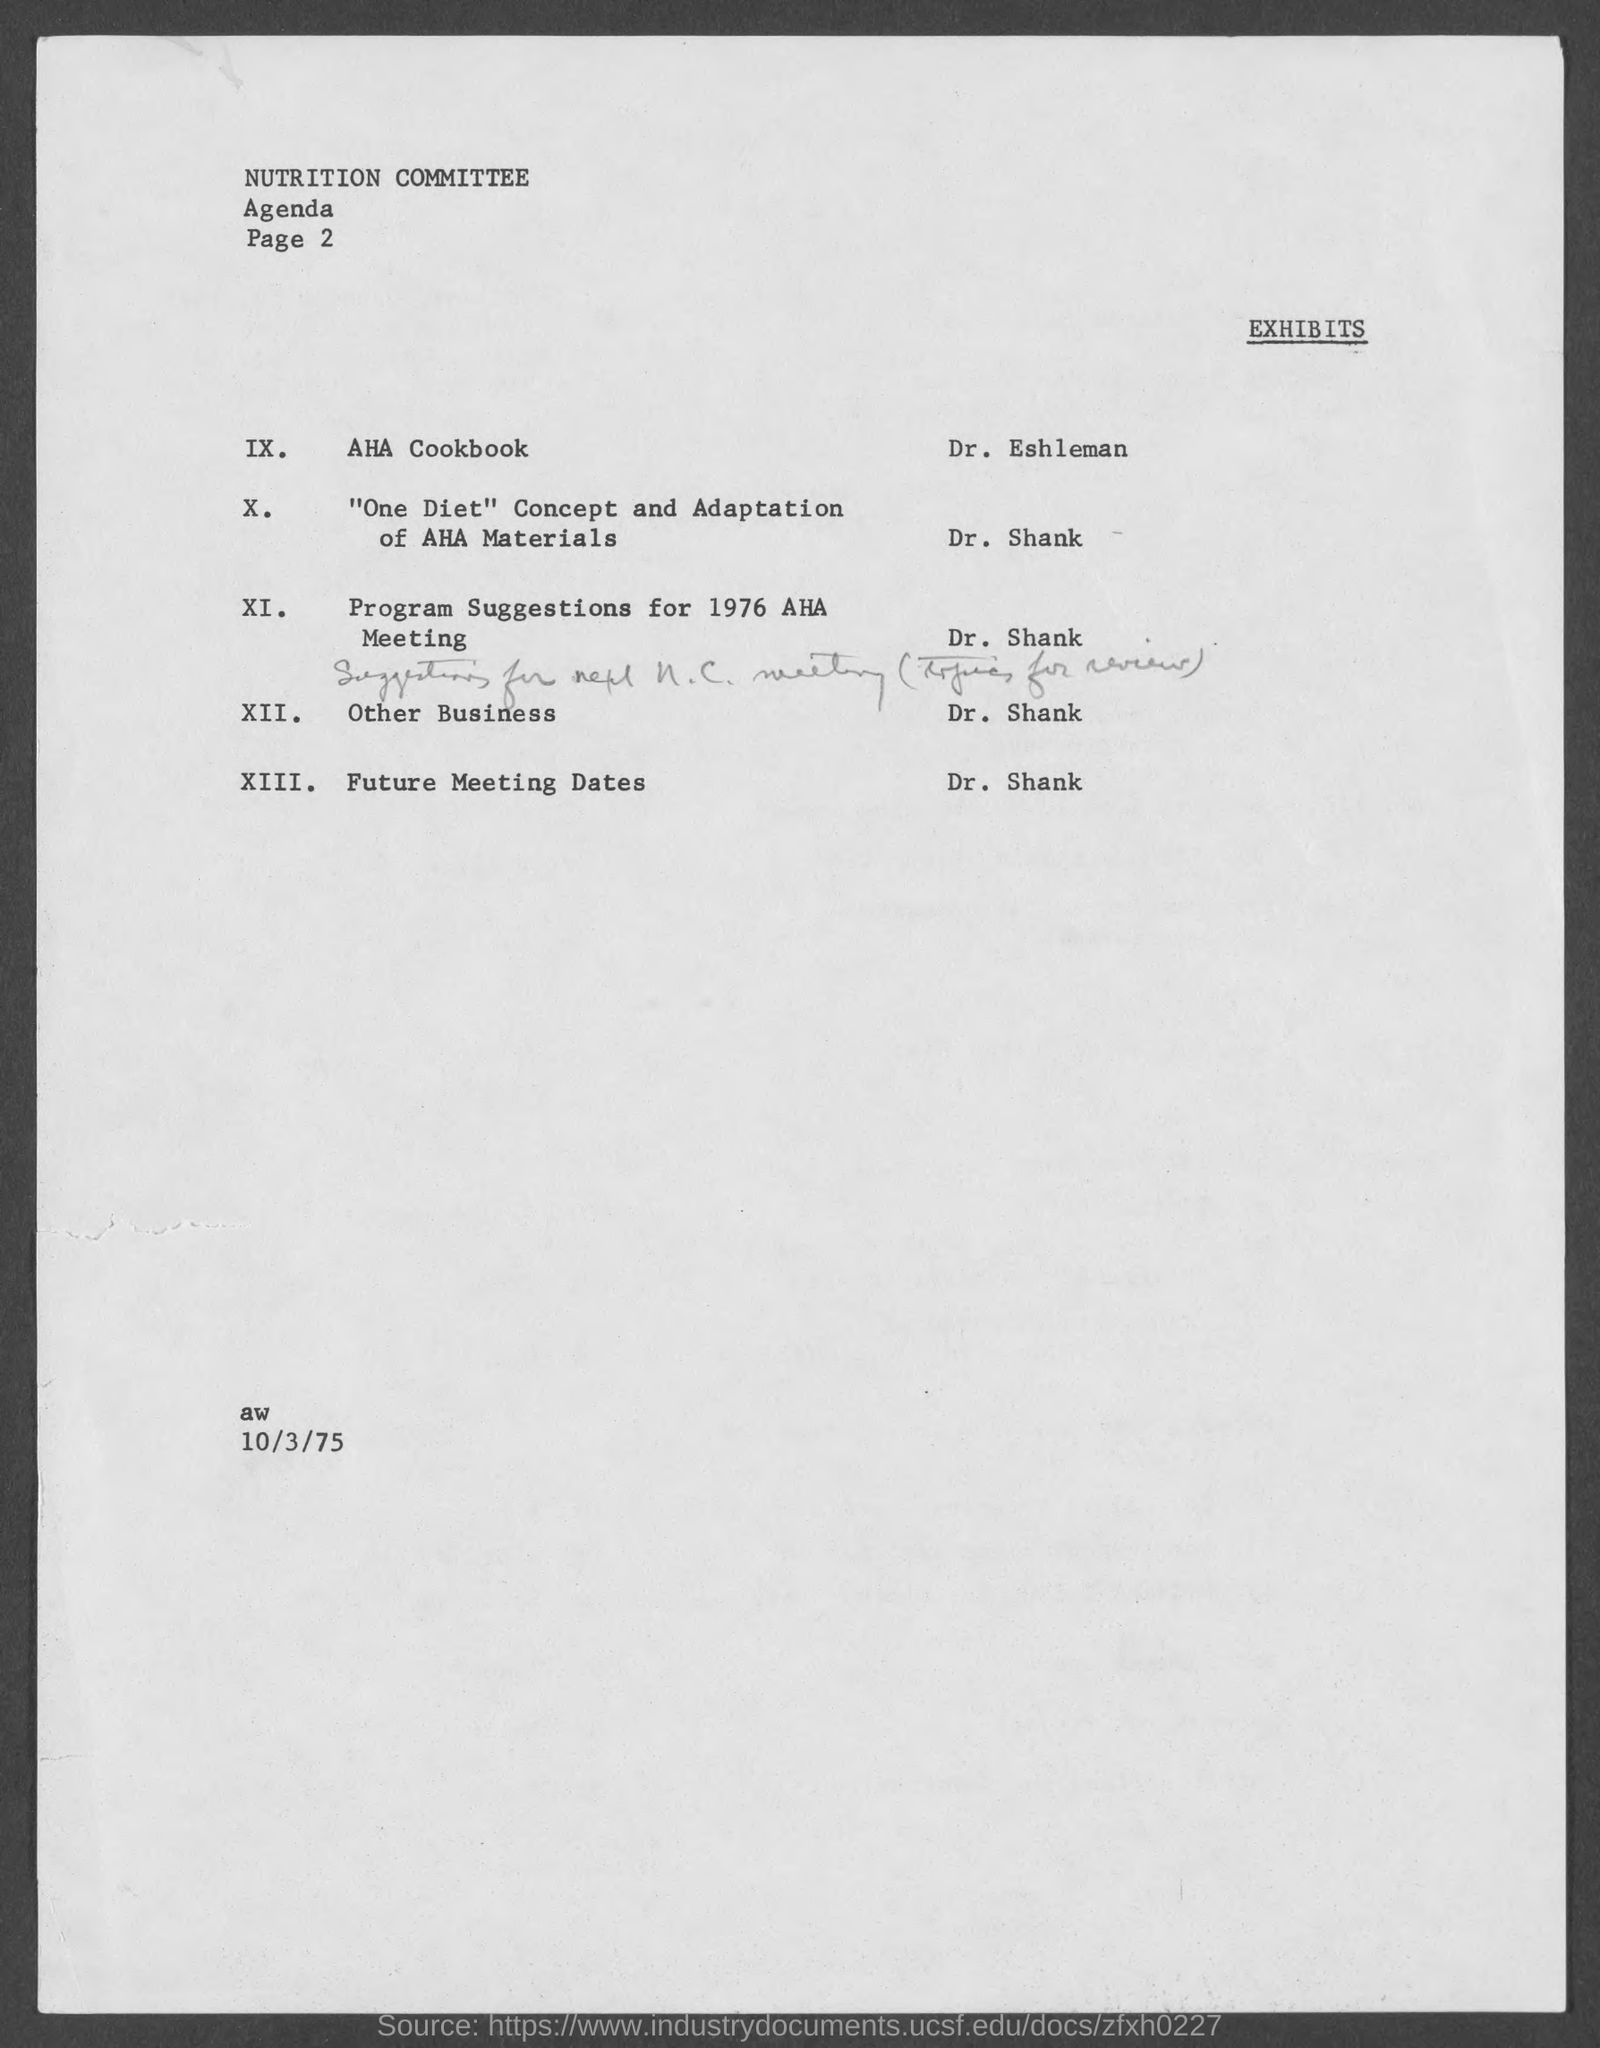What is the date on the document?
Provide a short and direct response. 10/3/75. 